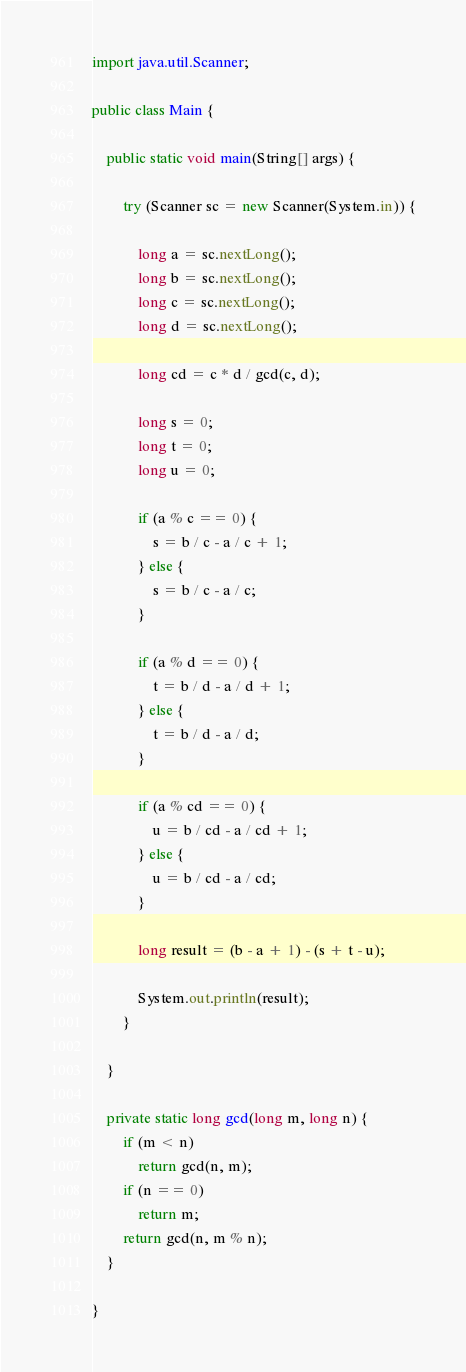Convert code to text. <code><loc_0><loc_0><loc_500><loc_500><_Java_>import java.util.Scanner;

public class Main {

	public static void main(String[] args) {

		try (Scanner sc = new Scanner(System.in)) {

			long a = sc.nextLong();
			long b = sc.nextLong();
			long c = sc.nextLong();
			long d = sc.nextLong();

			long cd = c * d / gcd(c, d);

			long s = 0;
			long t = 0;
			long u = 0;

			if (a % c == 0) {
				s = b / c - a / c + 1;
			} else {
				s = b / c - a / c;
			}

			if (a % d == 0) {
				t = b / d - a / d + 1;
			} else {
				t = b / d - a / d;
			}

			if (a % cd == 0) {
				u = b / cd - a / cd + 1;
			} else {
				u = b / cd - a / cd;
			}

			long result = (b - a + 1) - (s + t - u);

			System.out.println(result);
		}

	}

	private static long gcd(long m, long n) {
		if (m < n)
			return gcd(n, m);
		if (n == 0)
			return m;
		return gcd(n, m % n);
	}

}
</code> 